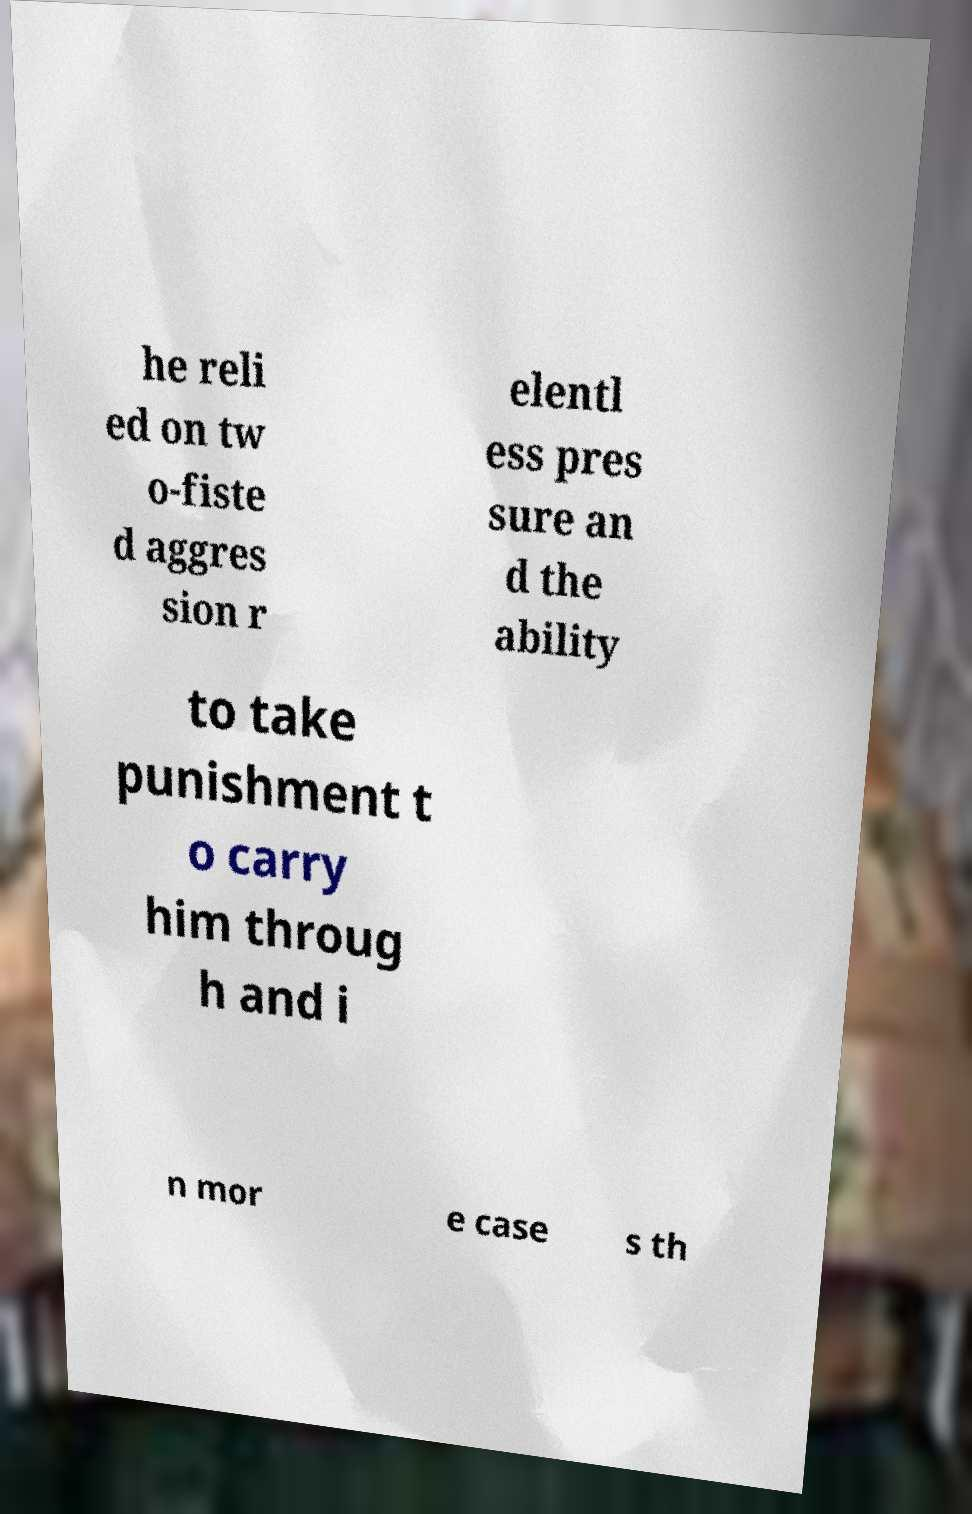Can you read and provide the text displayed in the image?This photo seems to have some interesting text. Can you extract and type it out for me? he reli ed on tw o-fiste d aggres sion r elentl ess pres sure an d the ability to take punishment t o carry him throug h and i n mor e case s th 